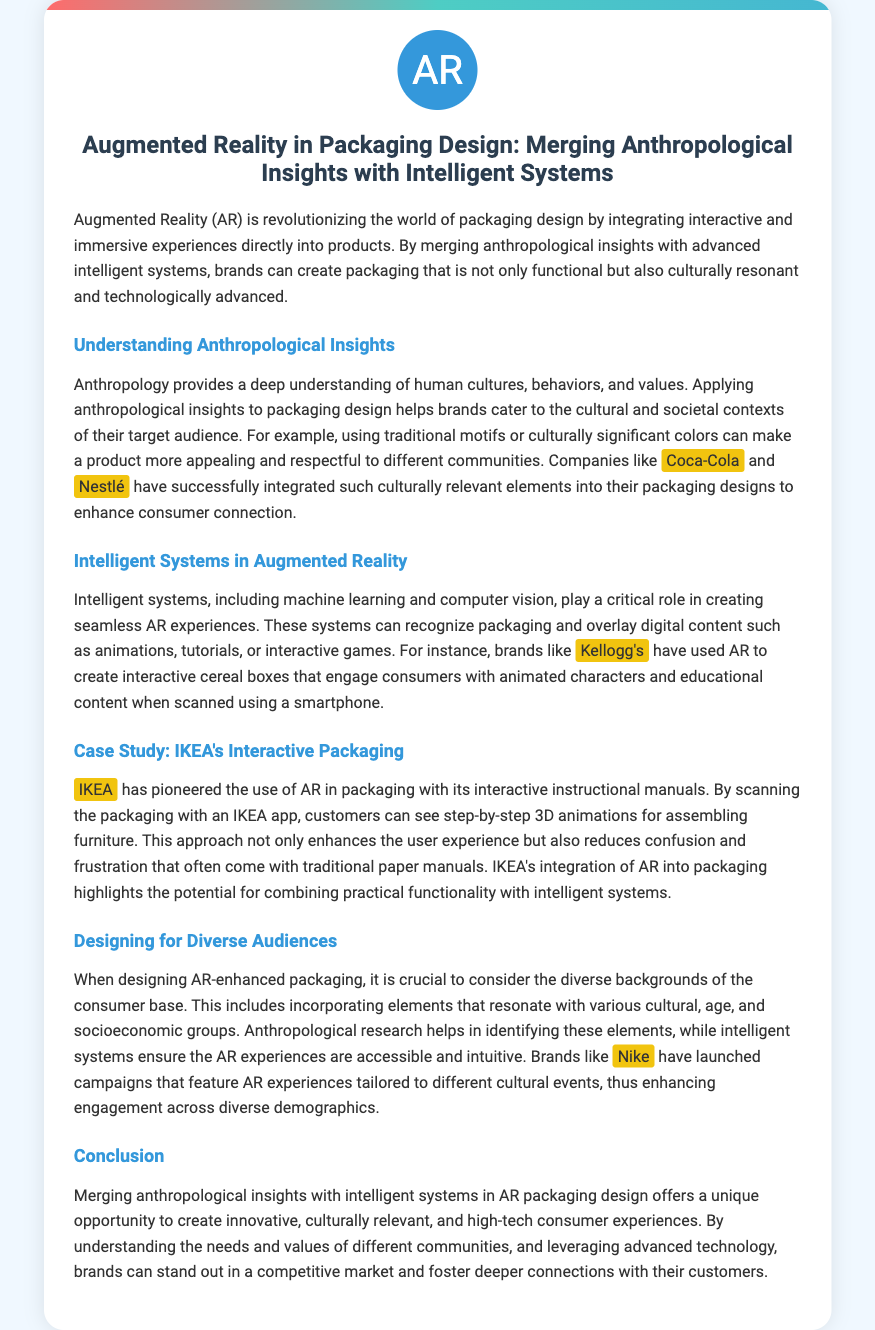What is the primary technology discussed in the document? The document focuses on Augmented Reality (AR) as the primary technology in packaging design.
Answer: Augmented Reality (AR) Which brands are mentioned as examples of integrating cultural elements in packaging? Brands like Coca-Cola and Nestlé are cited for incorporating culturally relevant designs in their packaging.
Answer: Coca-Cola, Nestlé What does IKEA use AR for in its packaging? IKEA utilizes AR in its packaging for providing interactive instructional manuals for furniture assembly.
Answer: Interactive instructional manuals Which brand is mentioned for using AR in cereal boxes? The brand Kellogg's is highlighted for creating interactive cereal boxes with AR.
Answer: Kellogg's Why is anthropological research important in AR packaging design? Anthropological research helps identify cultural elements that resonate with diverse consumer backgrounds.
Answer: Identifying cultural elements What type of systems are used alongside AR technology in packaging? Intelligent systems, including machine learning and computer vision, are used with AR in packaging.
Answer: Intelligent systems What is the goal of merging anthropology with AR in packaging design? The goal is to create innovative, culturally relevant, and high-tech consumer experiences.
Answer: Innovative, culturally relevant experiences Which company provides a case study in the document? IKEA is presented as a case study in the application of AR in packaging.
Answer: IKEA How does Nike enhance engagement through AR? Nike tailors AR experiences to different cultural events to enhance consumer engagement.
Answer: Tailoring AR experiences 